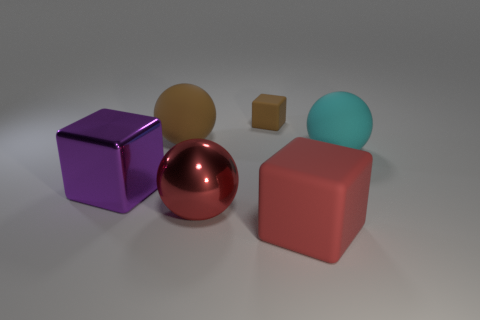Subtract all matte spheres. How many spheres are left? 1 Add 1 big yellow matte blocks. How many objects exist? 7 Add 3 large yellow shiny blocks. How many large yellow shiny blocks exist? 3 Subtract 0 purple spheres. How many objects are left? 6 Subtract all tiny brown blocks. Subtract all brown matte cubes. How many objects are left? 4 Add 1 big cyan objects. How many big cyan objects are left? 2 